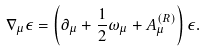Convert formula to latex. <formula><loc_0><loc_0><loc_500><loc_500>\nabla _ { \mu } \epsilon = \left ( \partial _ { \mu } + \frac { 1 } { 2 } \omega _ { \mu } + A _ { \mu } ^ { ( R ) } \right ) \epsilon .</formula> 